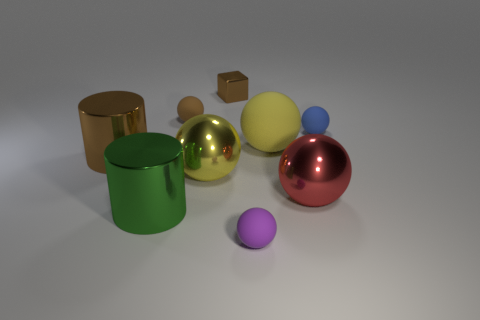Subtract all red shiny spheres. How many spheres are left? 5 Subtract all brown balls. How many balls are left? 5 Subtract all brown spheres. Subtract all red cubes. How many spheres are left? 5 Subtract all cylinders. How many objects are left? 7 Subtract 0 purple cylinders. How many objects are left? 9 Subtract all spheres. Subtract all small blue objects. How many objects are left? 2 Add 2 big brown things. How many big brown things are left? 3 Add 7 small blue spheres. How many small blue spheres exist? 8 